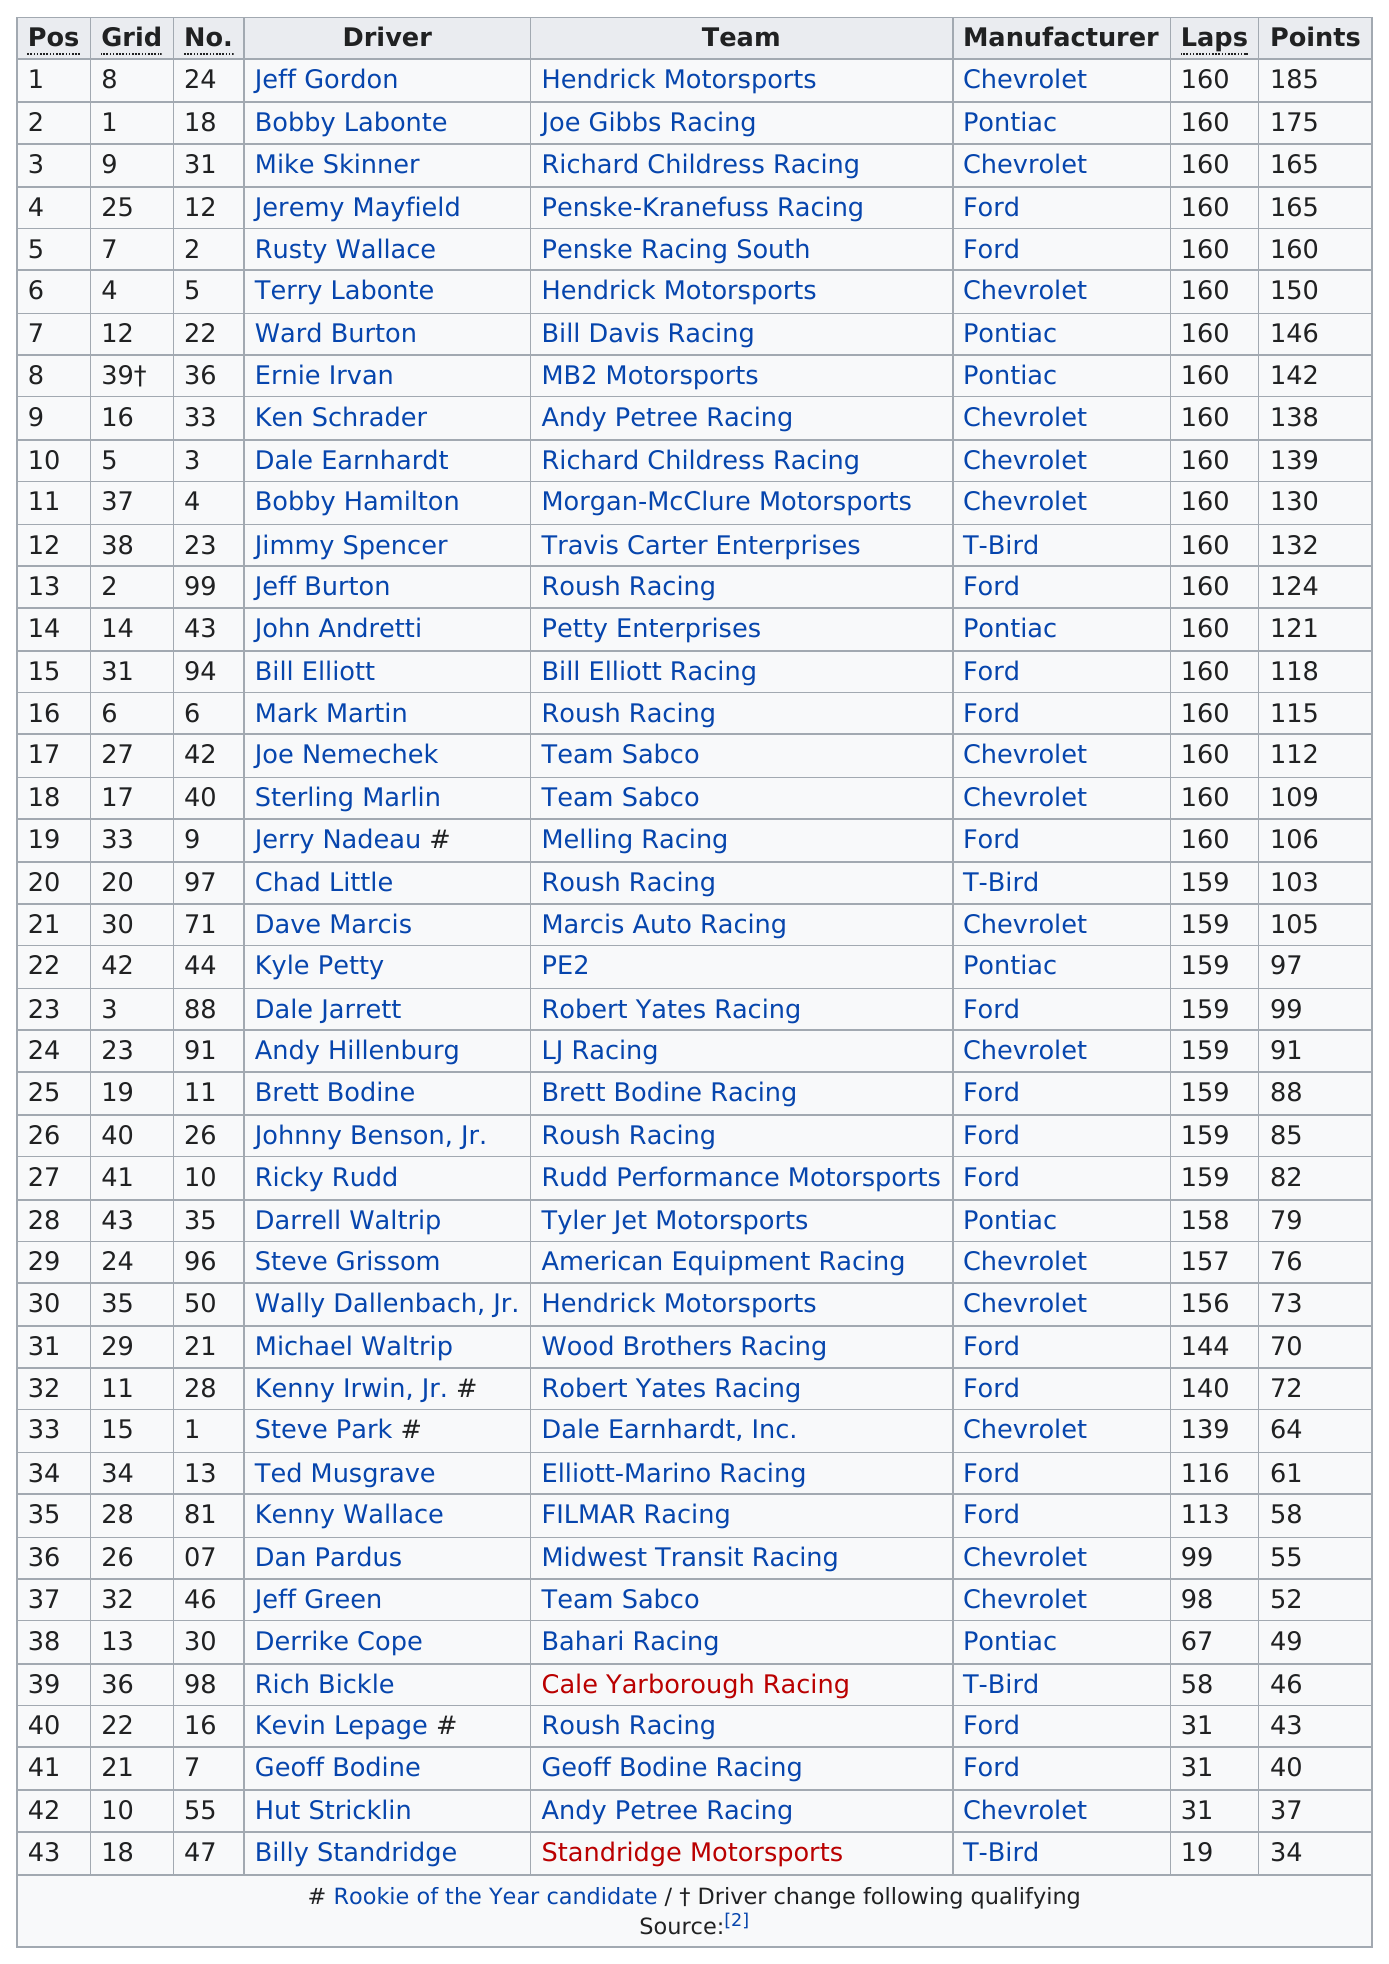Mention a couple of crucial points in this snapshot. The driver of the T-Bird that finished first was Jimmy Spencer. Ernie Irvan, the driver who completed 160 laps and accumulated 142 points, is the individual in question. It is false that 160 laps have been completed by drivers. 33 drivers did not have any top ten positions. Jeff Gordon had the most points, making him the clear winner. 